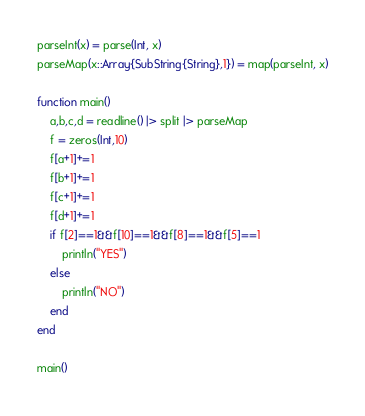Convert code to text. <code><loc_0><loc_0><loc_500><loc_500><_Julia_>parseInt(x) = parse(Int, x)
parseMap(x::Array{SubString{String},1}) = map(parseInt, x)

function main()
	a,b,c,d = readline() |> split |> parseMap
	f = zeros(Int,10)
	f[a+1]+=1
	f[b+1]+=1
	f[c+1]+=1
	f[d+1]+=1
	if f[2]==1&&f[10]==1&&f[8]==1&&f[5]==1
		println("YES")
	else
		println("NO")
	end
end

main()</code> 